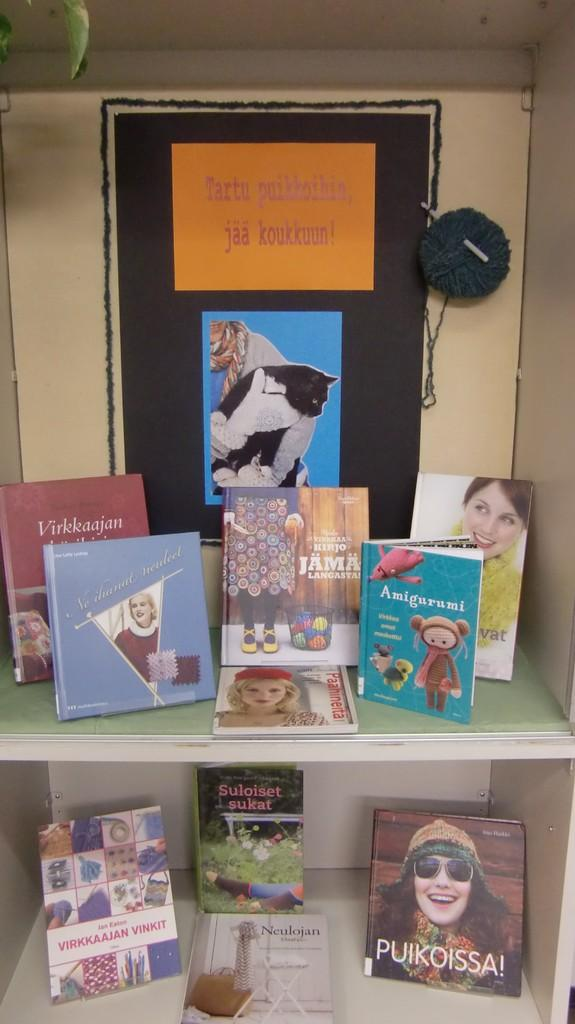<image>
Share a concise interpretation of the image provided. A shelf displaying several books including one called Amigurumi 